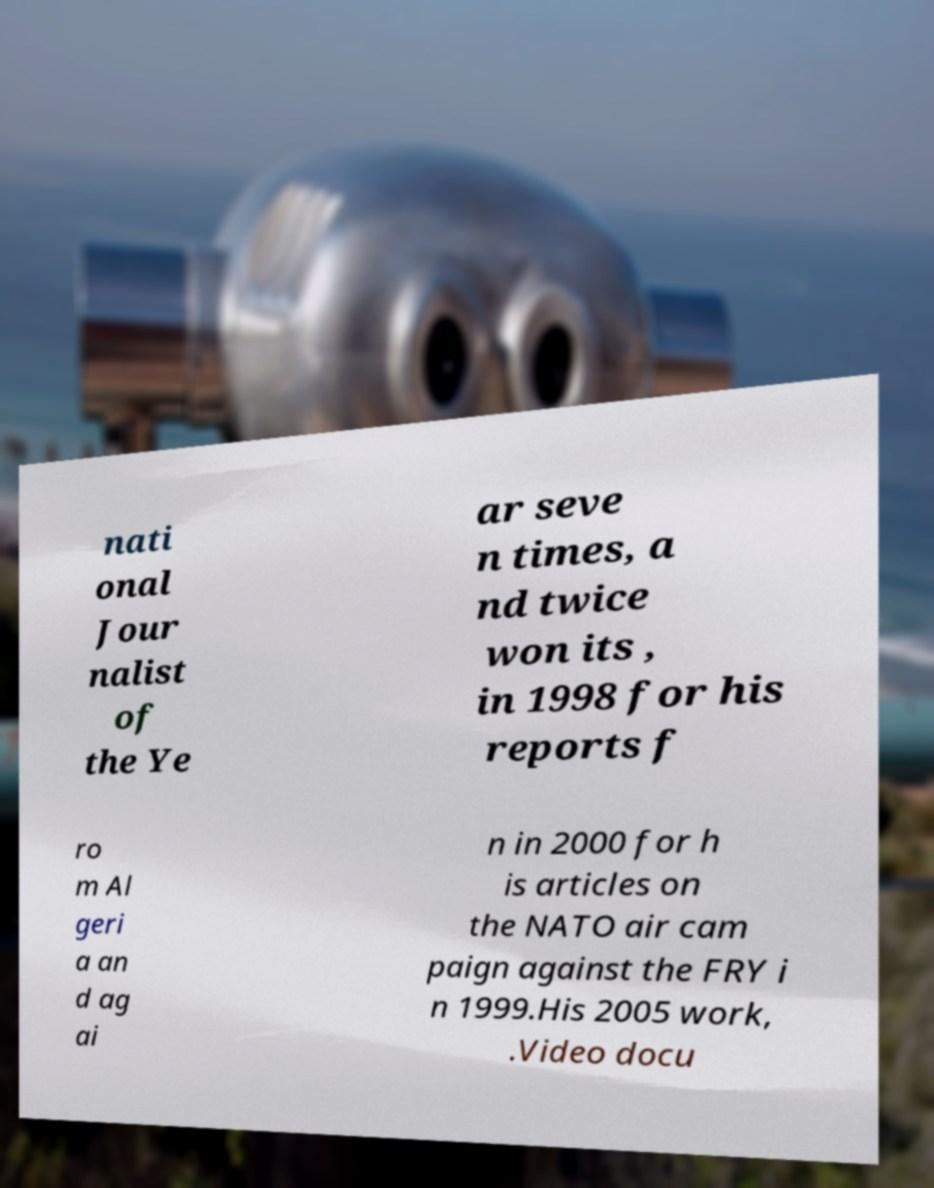What messages or text are displayed in this image? I need them in a readable, typed format. nati onal Jour nalist of the Ye ar seve n times, a nd twice won its , in 1998 for his reports f ro m Al geri a an d ag ai n in 2000 for h is articles on the NATO air cam paign against the FRY i n 1999.His 2005 work, .Video docu 